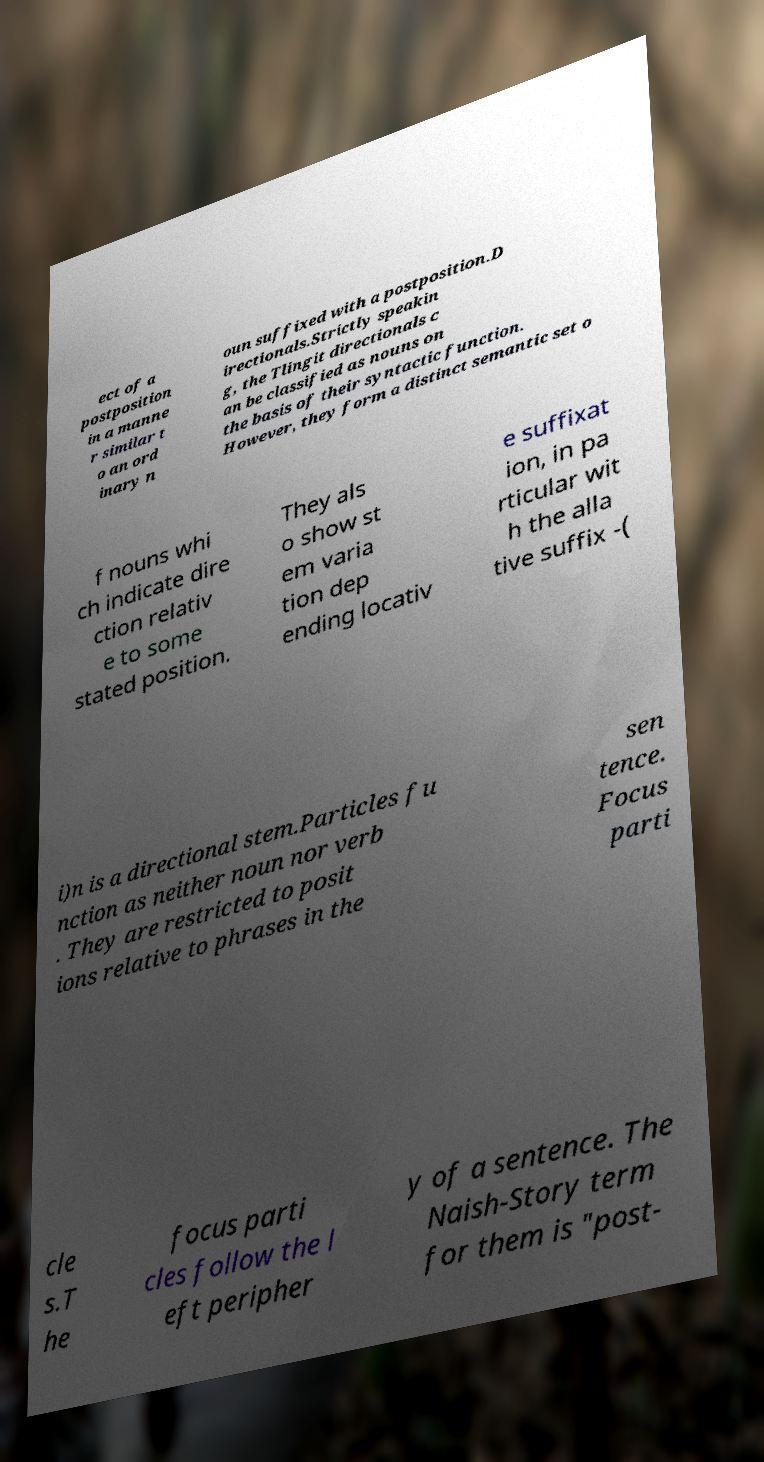Please read and relay the text visible in this image. What does it say? ect of a postposition in a manne r similar t o an ord inary n oun suffixed with a postposition.D irectionals.Strictly speakin g, the Tlingit directionals c an be classified as nouns on the basis of their syntactic function. However, they form a distinct semantic set o f nouns whi ch indicate dire ction relativ e to some stated position. They als o show st em varia tion dep ending locativ e suffixat ion, in pa rticular wit h the alla tive suffix -( i)n is a directional stem.Particles fu nction as neither noun nor verb . They are restricted to posit ions relative to phrases in the sen tence. Focus parti cle s.T he focus parti cles follow the l eft peripher y of a sentence. The Naish-Story term for them is "post- 